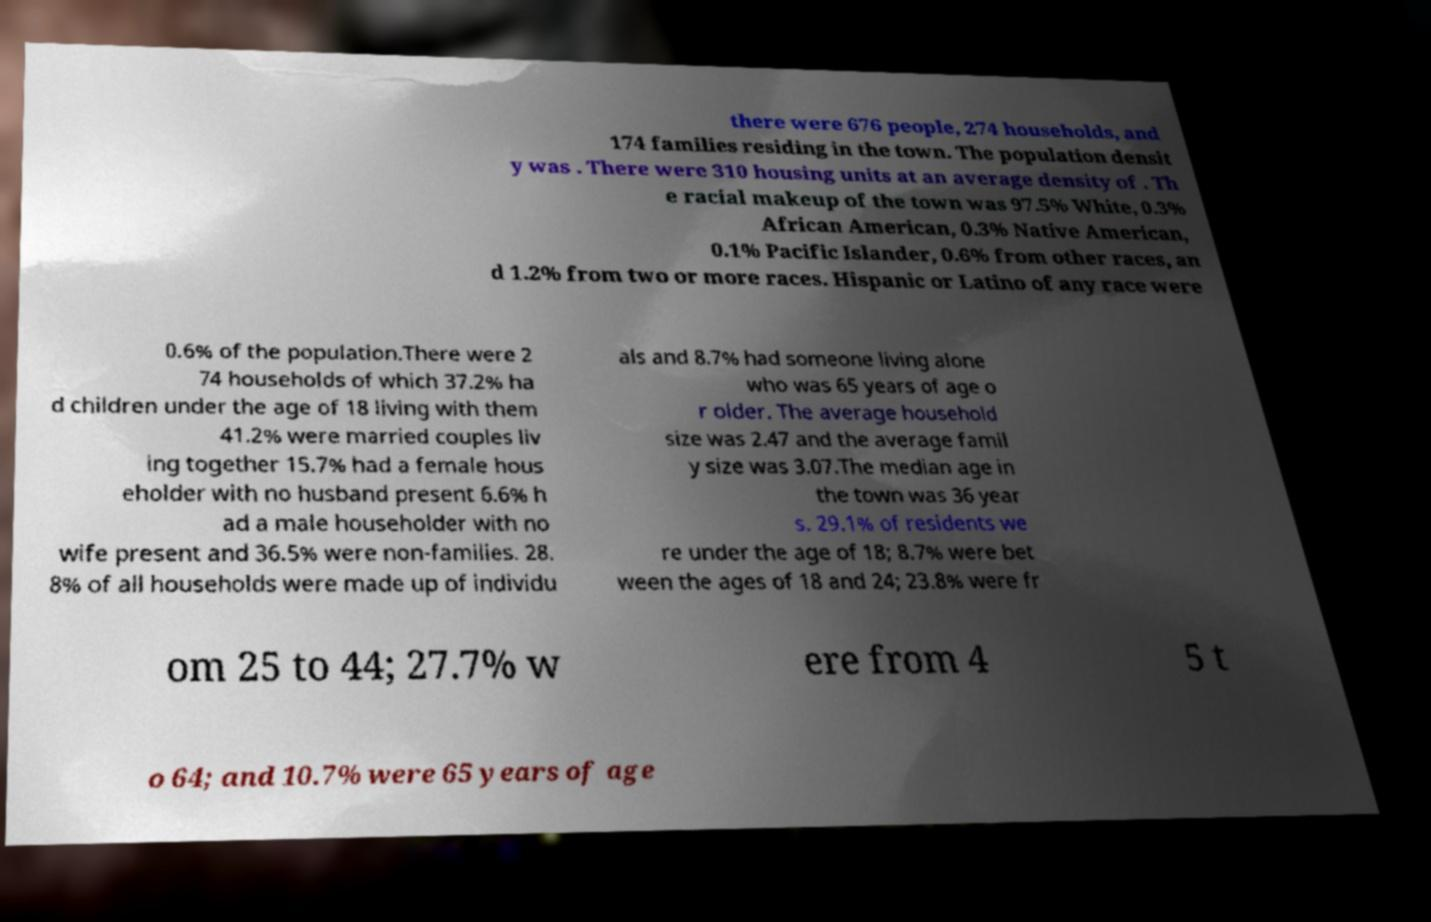There's text embedded in this image that I need extracted. Can you transcribe it verbatim? there were 676 people, 274 households, and 174 families residing in the town. The population densit y was . There were 310 housing units at an average density of . Th e racial makeup of the town was 97.5% White, 0.3% African American, 0.3% Native American, 0.1% Pacific Islander, 0.6% from other races, an d 1.2% from two or more races. Hispanic or Latino of any race were 0.6% of the population.There were 2 74 households of which 37.2% ha d children under the age of 18 living with them 41.2% were married couples liv ing together 15.7% had a female hous eholder with no husband present 6.6% h ad a male householder with no wife present and 36.5% were non-families. 28. 8% of all households were made up of individu als and 8.7% had someone living alone who was 65 years of age o r older. The average household size was 2.47 and the average famil y size was 3.07.The median age in the town was 36 year s. 29.1% of residents we re under the age of 18; 8.7% were bet ween the ages of 18 and 24; 23.8% were fr om 25 to 44; 27.7% w ere from 4 5 t o 64; and 10.7% were 65 years of age 